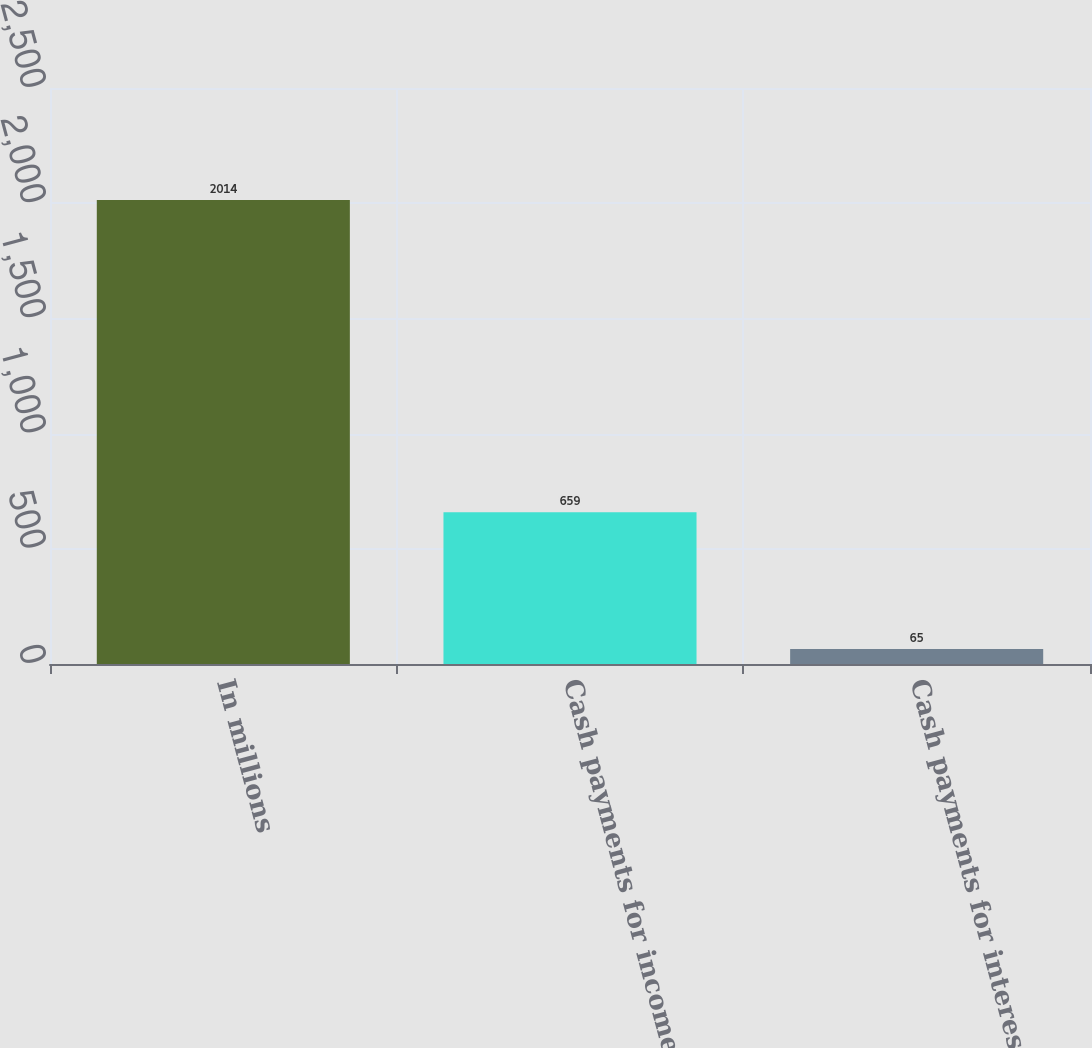Convert chart. <chart><loc_0><loc_0><loc_500><loc_500><bar_chart><fcel>In millions<fcel>Cash payments for income taxes<fcel>Cash payments for interest net<nl><fcel>2014<fcel>659<fcel>65<nl></chart> 